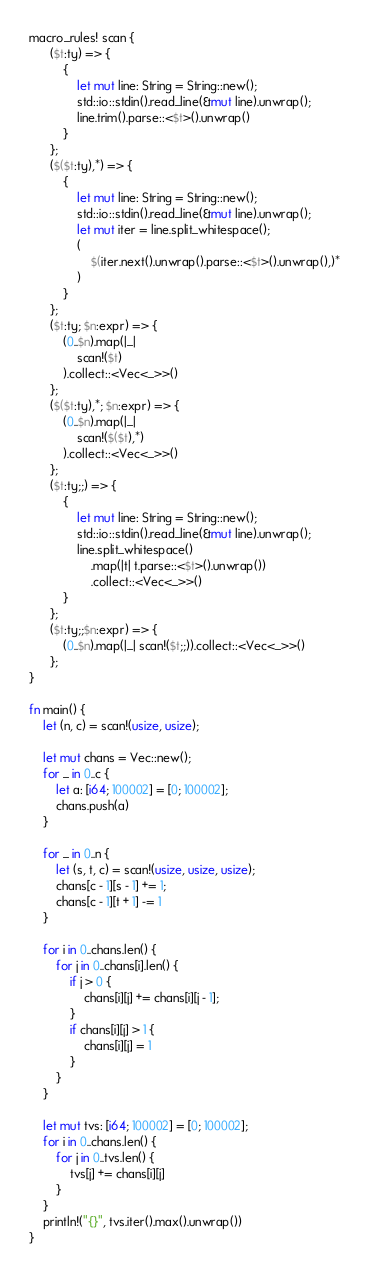Convert code to text. <code><loc_0><loc_0><loc_500><loc_500><_Rust_>macro_rules! scan {
      ($t:ty) => {
          {
              let mut line: String = String::new();
              std::io::stdin().read_line(&mut line).unwrap();
              line.trim().parse::<$t>().unwrap()
          }
      };
      ($($t:ty),*) => {
          {
              let mut line: String = String::new();
              std::io::stdin().read_line(&mut line).unwrap();
              let mut iter = line.split_whitespace();
              (
                  $(iter.next().unwrap().parse::<$t>().unwrap(),)*
              )
          }
      };
      ($t:ty; $n:expr) => {
          (0..$n).map(|_|
              scan!($t)
          ).collect::<Vec<_>>()
      };
      ($($t:ty),*; $n:expr) => {
          (0..$n).map(|_|
              scan!($($t),*)
          ).collect::<Vec<_>>()
      };
      ($t:ty;;) => {
          {
              let mut line: String = String::new();
              std::io::stdin().read_line(&mut line).unwrap();
              line.split_whitespace()
                  .map(|t| t.parse::<$t>().unwrap())
                  .collect::<Vec<_>>()
          }
      };
      ($t:ty;;$n:expr) => {
          (0..$n).map(|_| scan!($t;;)).collect::<Vec<_>>()
      };
}

fn main() {
    let (n, c) = scan!(usize, usize);

    let mut chans = Vec::new();
    for _ in 0..c {
        let a: [i64; 100002] = [0; 100002];
        chans.push(a)
    }

    for _ in 0..n {
        let (s, t, c) = scan!(usize, usize, usize);
        chans[c - 1][s - 1] += 1;
        chans[c - 1][t + 1] -= 1
    }

    for i in 0..chans.len() {
        for j in 0..chans[i].len() {
            if j > 0 {
                chans[i][j] += chans[i][j - 1];
            }
            if chans[i][j] > 1 {
                chans[i][j] = 1
            }
        }
    }

    let mut tvs: [i64; 100002] = [0; 100002];
    for i in 0..chans.len() {
        for j in 0..tvs.len() {
            tvs[j] += chans[i][j]
        }
    }
    println!("{}", tvs.iter().max().unwrap())
}
</code> 